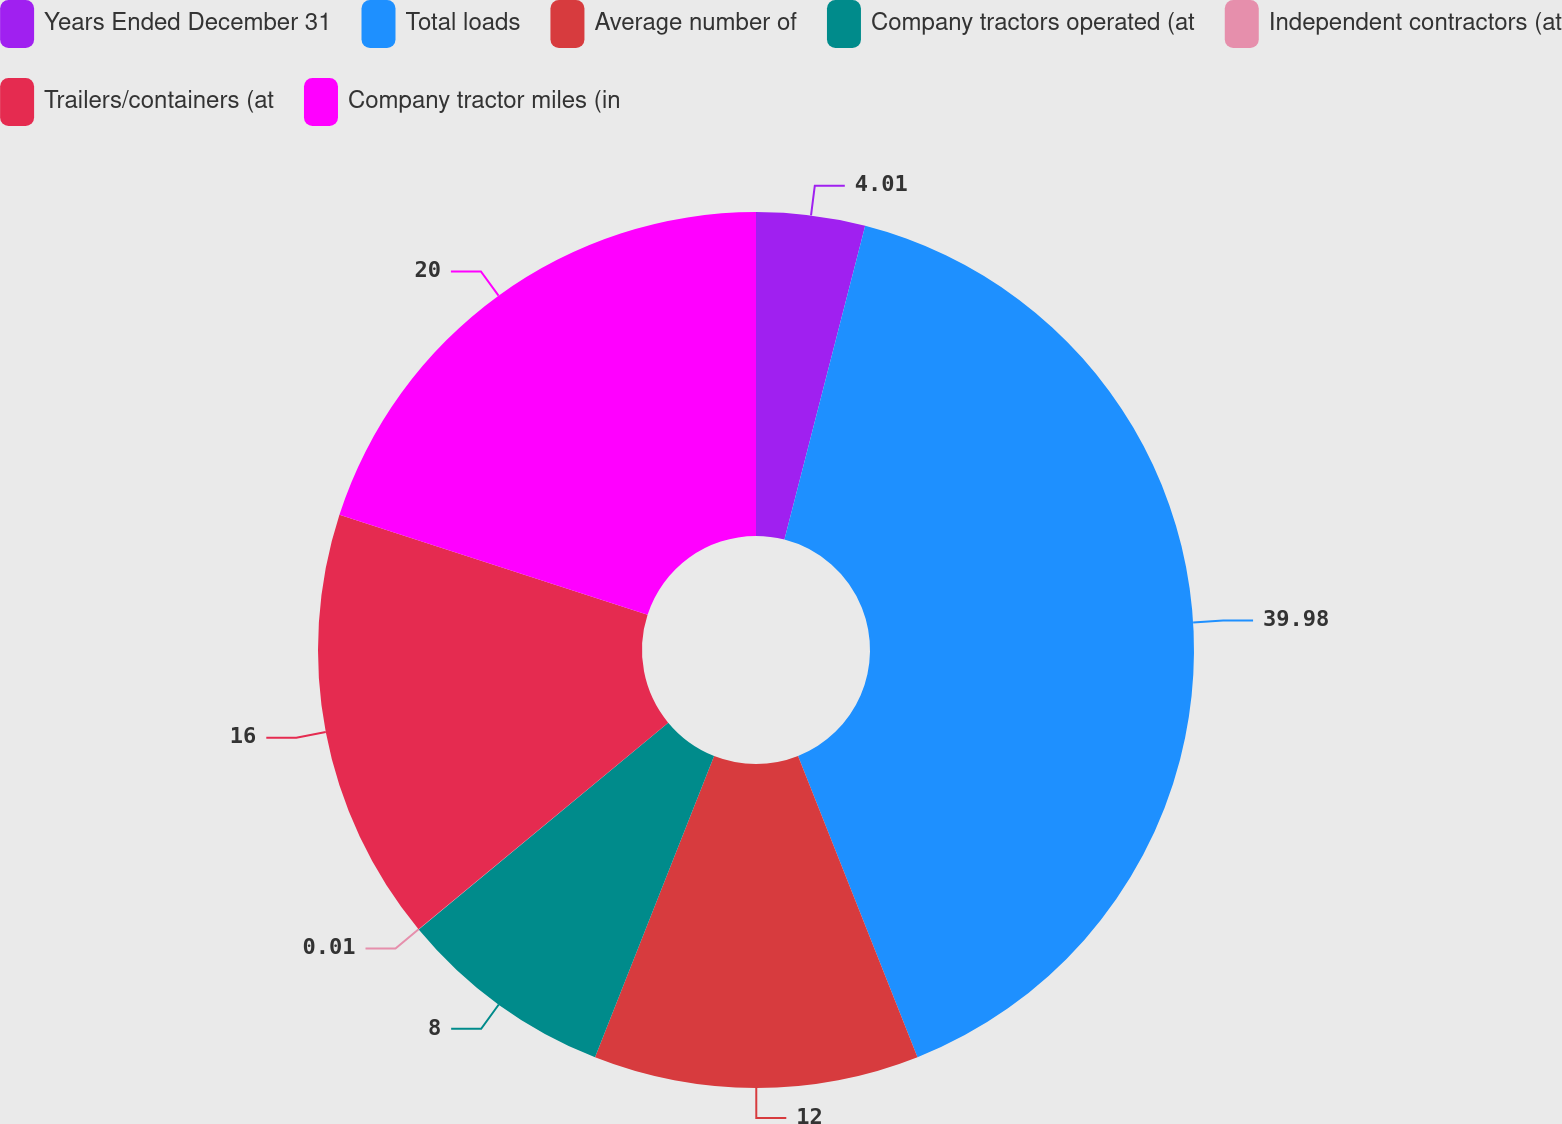Convert chart. <chart><loc_0><loc_0><loc_500><loc_500><pie_chart><fcel>Years Ended December 31<fcel>Total loads<fcel>Average number of<fcel>Company tractors operated (at<fcel>Independent contractors (at<fcel>Trailers/containers (at<fcel>Company tractor miles (in<nl><fcel>4.01%<fcel>39.98%<fcel>12.0%<fcel>8.0%<fcel>0.01%<fcel>16.0%<fcel>20.0%<nl></chart> 